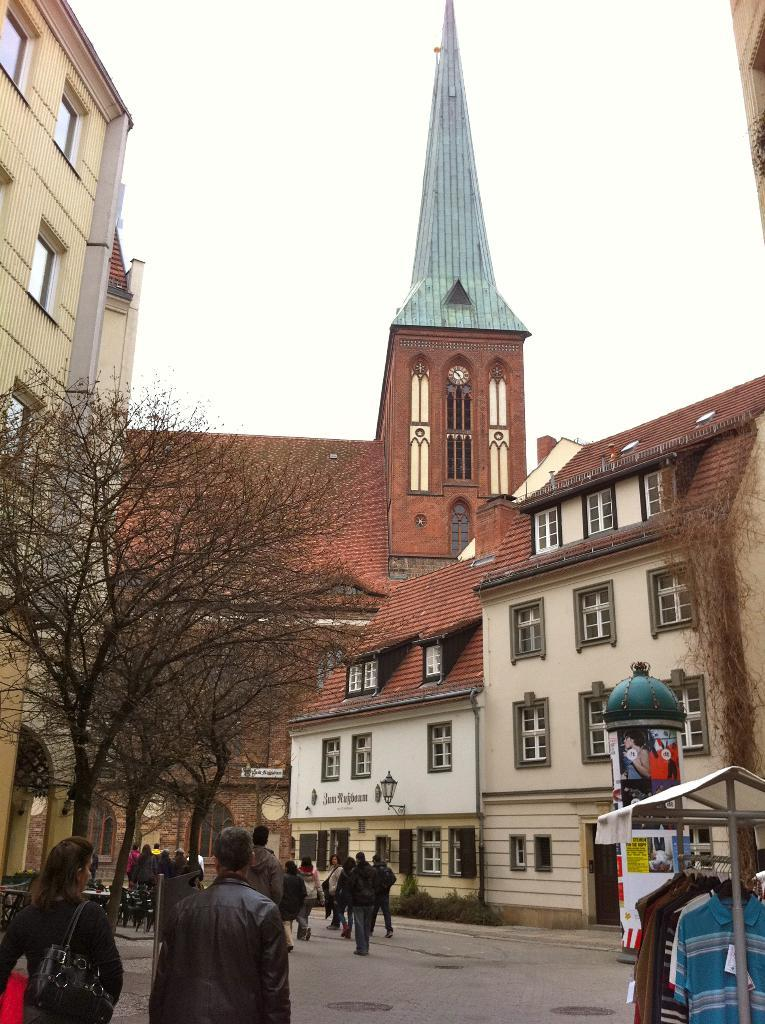What can be seen in the image involving people? There are people standing in the image. What type of structures are present in the image? There are buildings in the image. What other natural elements can be seen in the image? There are trees in the image. What is being used to hold clothes in the image? There is a clothes stand with clothes in the image. What is visible in the background of the image? The sky is visible in the background of the image. Who is the creator of the story depicted in the image? There is no story depicted in the image, so it is not possible to determine the creator. Where is the shelf located in the image? There is no shelf present in the image. 